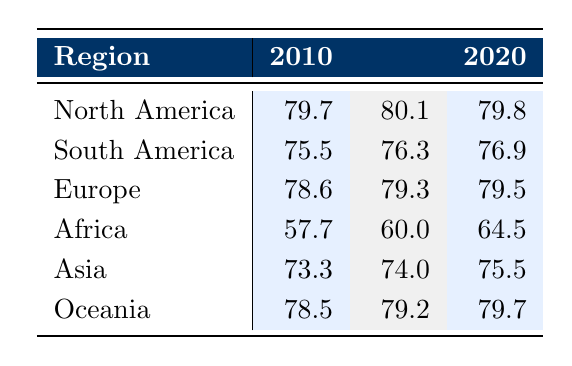What was the life expectancy in North America in 2010? Referring to the table, the life expectancy in North America for the year 2010 is listed directly as 79.7.
Answer: 79.7 What was the percentage increase in life expectancy in Africa from 2010 to 2020? The life expectancy in Africa in 2010 was 57.7, and in 2020 it rose to 64.5. To find the percentage increase: (64.5 - 57.7) / 57.7 * 100 = 12.5%.
Answer: 12.5% Did life expectancy in Asia improve from 2010 to 2015? Comparing the values, the life expectancy in Asia was 73.3 in 2010 and 74.0 in 2015. Since 74.0 is greater than 73.3, it indicates an improvement.
Answer: Yes What is the average life expectancy for all regions in 2015? The life expectancies for each region in 2015 are: North America (80.1), South America (76.3), Europe (79.3), Africa (60.0), Asia (74.0), and Oceania (79.2). Summing these (80.1 + 76.3 + 79.3 + 60.0 + 74.0 + 79.2) gives a total of 449. The average is 449 / 6 = 74.83.
Answer: 74.83 Which region had the highest life expectancy in 2020? By comparing the values for each region in 2020, North America has 79.8, South America 76.9, Europe 79.5, Africa 64.5, Asia 75.5, and Oceania 79.7. The highest value is 79.8, belonging to North America.
Answer: North America Was the life expectancy in Europe higher than that in South America in 2010? In 2010, Europe had a life expectancy of 78.6 while South America had 75.5. Since 78.6 is greater than 75.5, Europe did indeed have a higher life expectancy.
Answer: Yes What was the difference in life expectancy between Oceania and Africa in 2015? In 2015, the life expectancy in Oceania was 79.2, and in Africa, it was 60.0. The difference is 79.2 - 60.0 = 19.2.
Answer: 19.2 In which year did Asia's life expectancy first exceed 75? Looking at the values for Asia, the life expectancies were 73.3 in 2010, 74.0 in 2015, and 75.5 in 2020. The first instance of exceeding 75 is in 2020.
Answer: 2020 What was the life expectancy trend for South America from 2010 to 2020? In South America, the life expectancy was 75.5 in 2010, increased to 76.3 in 2015, and further increased to 76.9 in 2020. This shows a consistent upward trend across these years.
Answer: Upward trend 